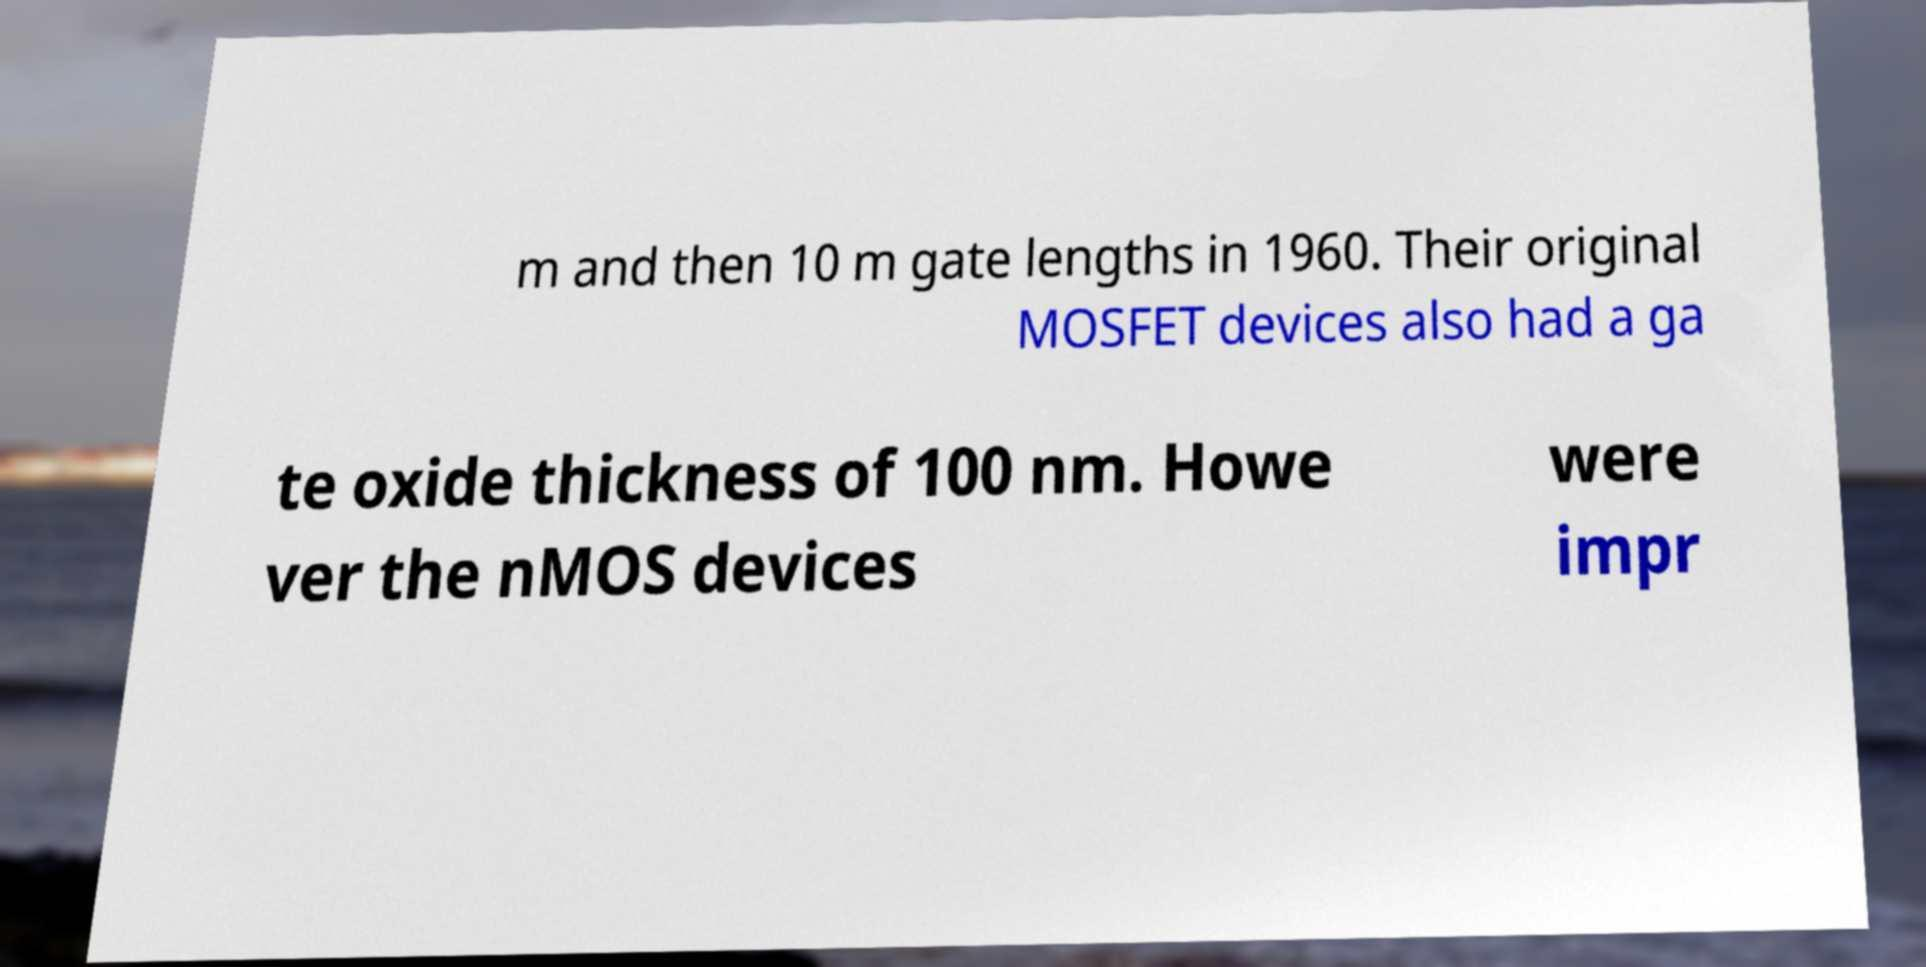There's text embedded in this image that I need extracted. Can you transcribe it verbatim? m and then 10 m gate lengths in 1960. Their original MOSFET devices also had a ga te oxide thickness of 100 nm. Howe ver the nMOS devices were impr 